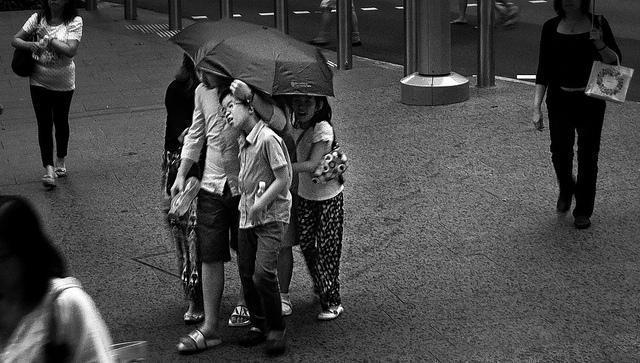What number is closest to how many people are under the middle umbrella?
From the following set of four choices, select the accurate answer to respond to the question.
Options: Four, one, twenty, ten. Four. 